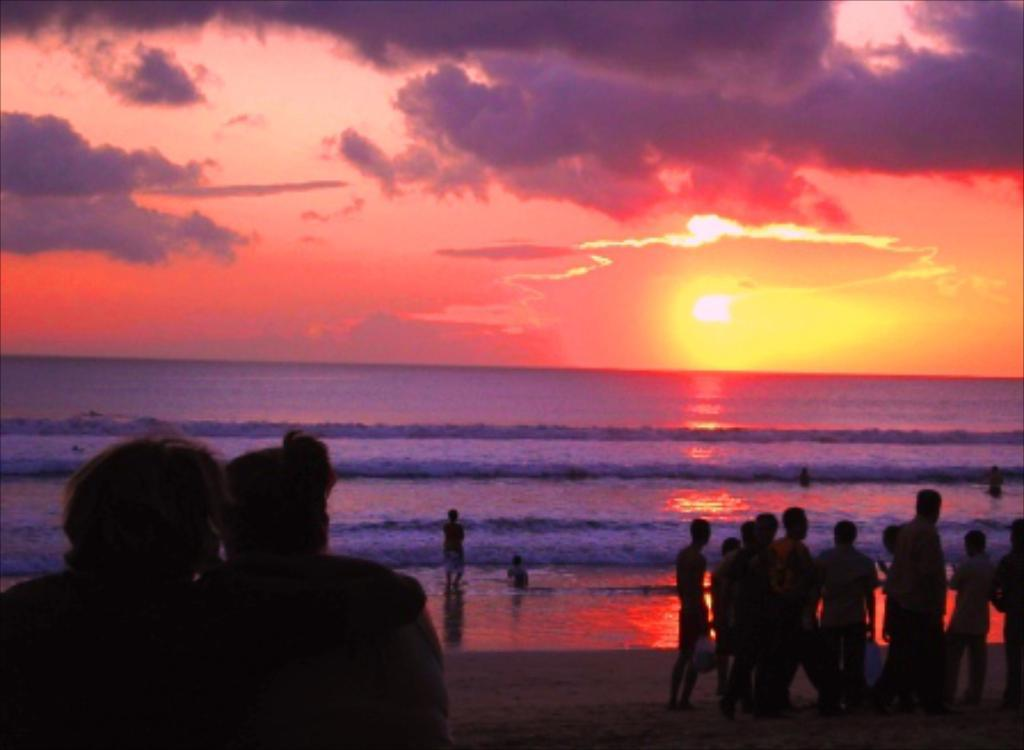What can be seen in the image? There are people standing in the image, and it contains a beach. What is visible in the water? There is no specific detail about the water in the image. What is the condition of the sky in the image? The sky is cloudy in the image. Can the sun be seen in the image? Yes, the sun is visible in the image. What type of knee injury is the farmer experiencing in the image? There is no farmer or knee injury present in the image. How many elbows can be seen in the image? The number of elbows visible in the image cannot be determined from the provided facts. 